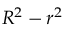Convert formula to latex. <formula><loc_0><loc_0><loc_500><loc_500>R ^ { 2 } - r ^ { 2 }</formula> 